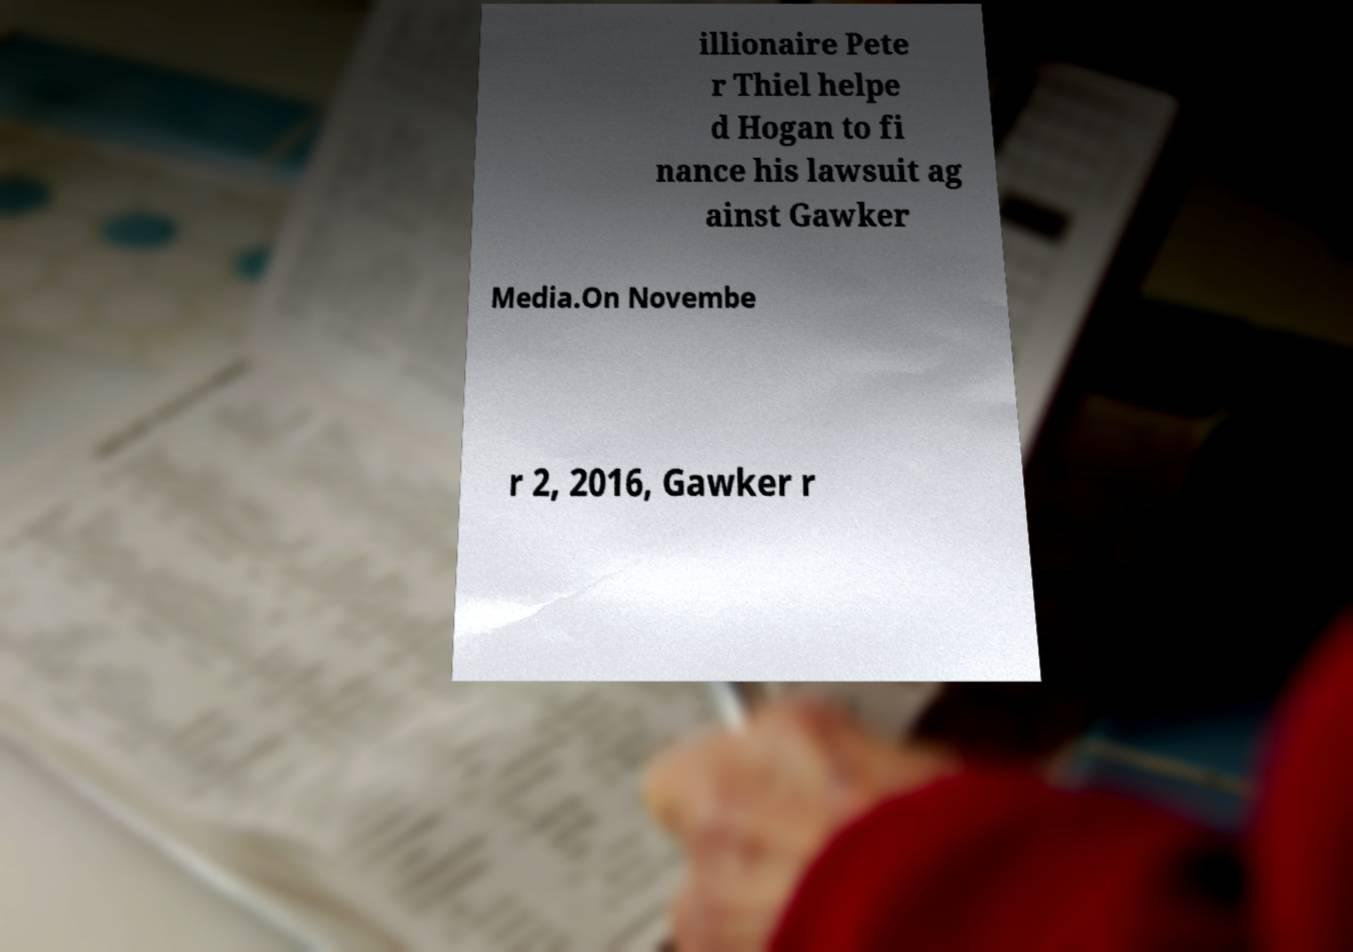Can you accurately transcribe the text from the provided image for me? illionaire Pete r Thiel helpe d Hogan to fi nance his lawsuit ag ainst Gawker Media.On Novembe r 2, 2016, Gawker r 